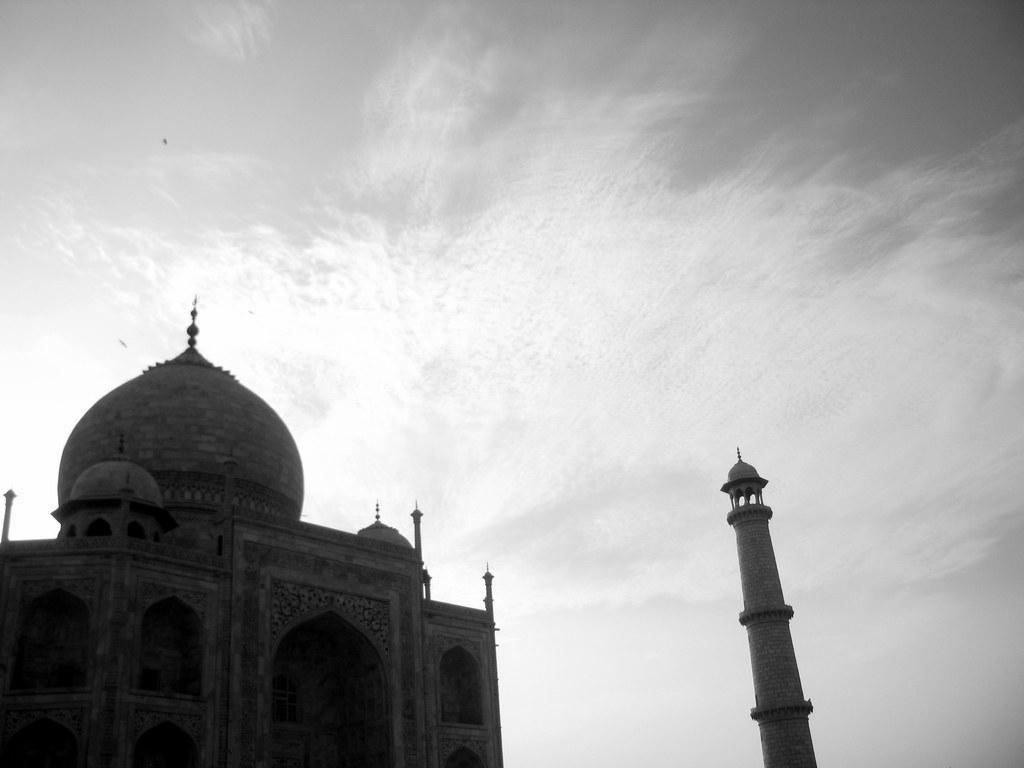Describe this image in one or two sentences. In the center of the image we can see the sky, clouds, one pillar and the monument. 